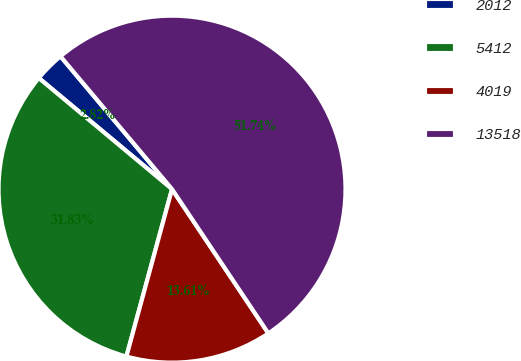Convert chart to OTSL. <chart><loc_0><loc_0><loc_500><loc_500><pie_chart><fcel>2012<fcel>5412<fcel>4019<fcel>13518<nl><fcel>2.82%<fcel>31.83%<fcel>13.61%<fcel>51.74%<nl></chart> 